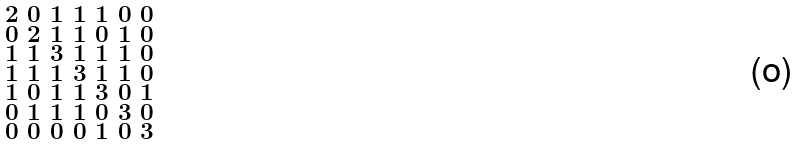Convert formula to latex. <formula><loc_0><loc_0><loc_500><loc_500>\begin{smallmatrix} 2 & 0 & 1 & 1 & 1 & 0 & 0 \\ 0 & 2 & 1 & 1 & 0 & 1 & 0 \\ 1 & 1 & 3 & 1 & 1 & 1 & 0 \\ 1 & 1 & 1 & 3 & 1 & 1 & 0 \\ 1 & 0 & 1 & 1 & 3 & 0 & 1 \\ 0 & 1 & 1 & 1 & 0 & 3 & 0 \\ 0 & 0 & 0 & 0 & 1 & 0 & 3 \end{smallmatrix}</formula> 